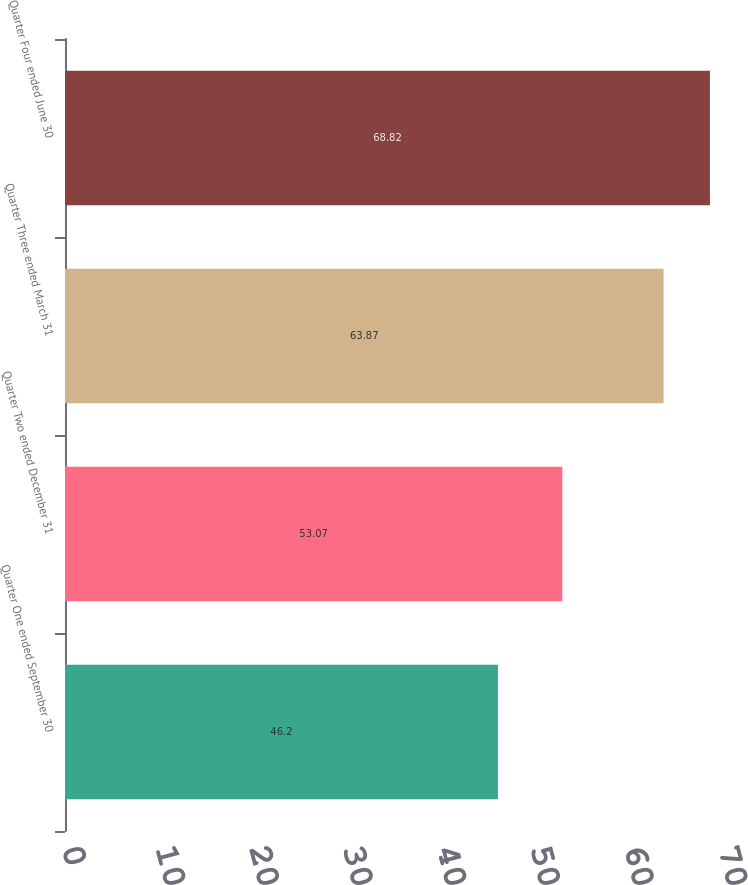<chart> <loc_0><loc_0><loc_500><loc_500><bar_chart><fcel>Quarter One ended September 30<fcel>Quarter Two ended December 31<fcel>Quarter Three ended March 31<fcel>Quarter Four ended June 30<nl><fcel>46.2<fcel>53.07<fcel>63.87<fcel>68.82<nl></chart> 